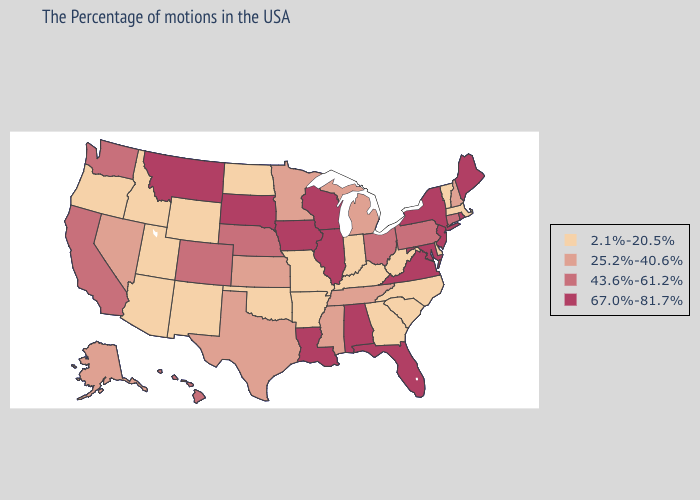Does Alaska have a lower value than California?
Short answer required. Yes. Name the states that have a value in the range 43.6%-61.2%?
Short answer required. Connecticut, Pennsylvania, Ohio, Nebraska, Colorado, California, Washington, Hawaii. What is the highest value in the Northeast ?
Be succinct. 67.0%-81.7%. Name the states that have a value in the range 67.0%-81.7%?
Quick response, please. Maine, Rhode Island, New York, New Jersey, Maryland, Virginia, Florida, Alabama, Wisconsin, Illinois, Louisiana, Iowa, South Dakota, Montana. Does Indiana have the highest value in the MidWest?
Keep it brief. No. Does California have a higher value than Indiana?
Short answer required. Yes. Name the states that have a value in the range 67.0%-81.7%?
Write a very short answer. Maine, Rhode Island, New York, New Jersey, Maryland, Virginia, Florida, Alabama, Wisconsin, Illinois, Louisiana, Iowa, South Dakota, Montana. Name the states that have a value in the range 2.1%-20.5%?
Write a very short answer. Massachusetts, Vermont, Delaware, North Carolina, South Carolina, West Virginia, Georgia, Kentucky, Indiana, Missouri, Arkansas, Oklahoma, North Dakota, Wyoming, New Mexico, Utah, Arizona, Idaho, Oregon. How many symbols are there in the legend?
Write a very short answer. 4. What is the value of New Hampshire?
Keep it brief. 25.2%-40.6%. What is the value of Connecticut?
Short answer required. 43.6%-61.2%. Does the map have missing data?
Answer briefly. No. What is the highest value in states that border Arkansas?
Be succinct. 67.0%-81.7%. Which states have the lowest value in the West?
Write a very short answer. Wyoming, New Mexico, Utah, Arizona, Idaho, Oregon. What is the value of Arkansas?
Concise answer only. 2.1%-20.5%. 